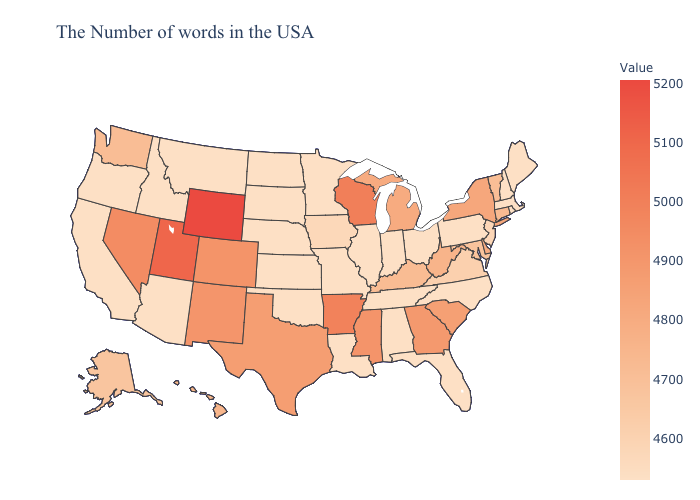Is the legend a continuous bar?
Short answer required. Yes. Among the states that border Delaware , which have the highest value?
Write a very short answer. Maryland. 